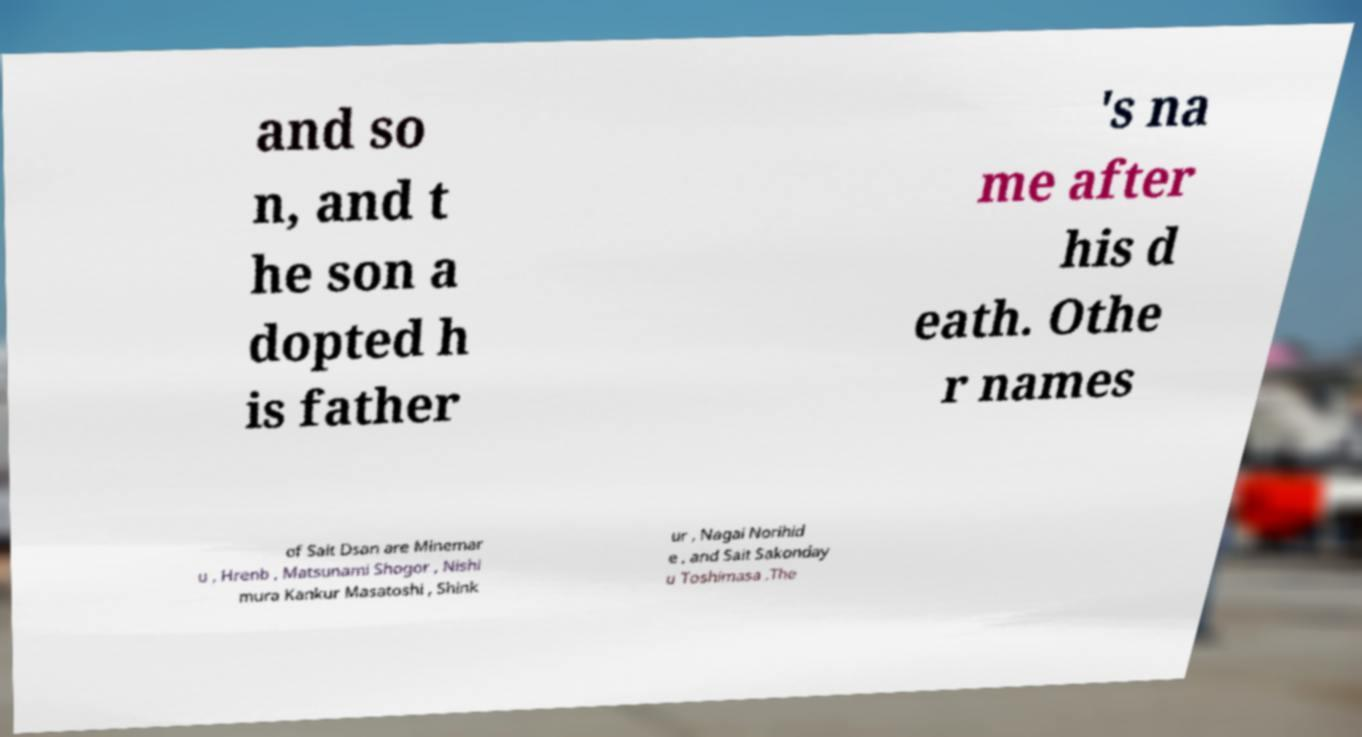For documentation purposes, I need the text within this image transcribed. Could you provide that? and so n, and t he son a dopted h is father 's na me after his d eath. Othe r names of Sait Dsan are Minemar u , Hrenb , Matsunami Shogor , Nishi mura Kankur Masatoshi , Shink ur , Nagai Norihid e , and Sait Sakonday u Toshimasa .The 